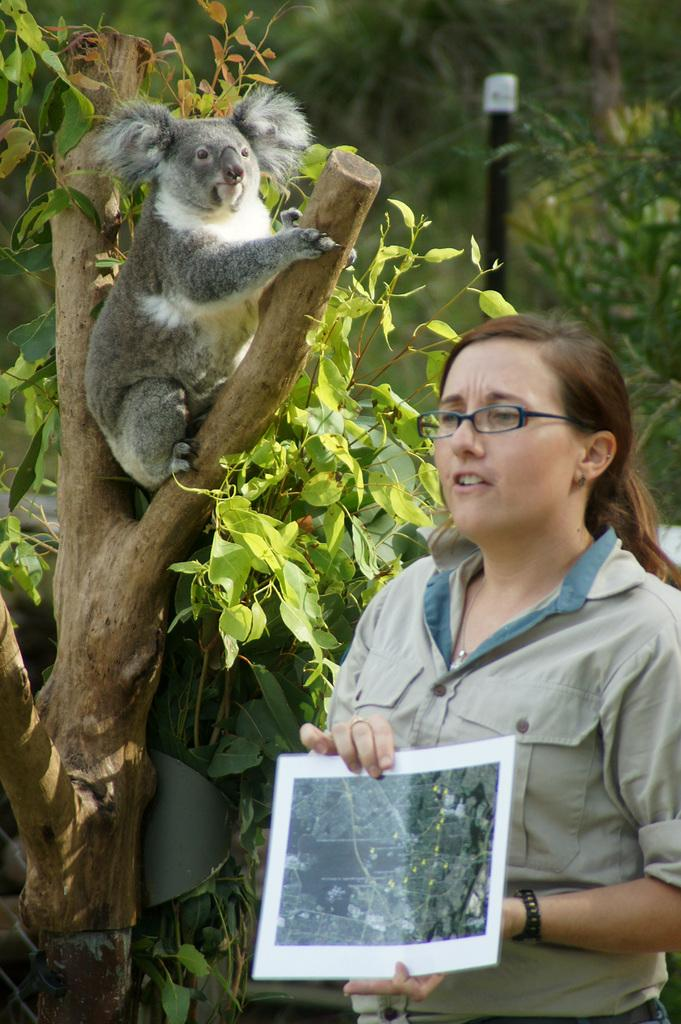Who is present in the image? There is a woman in the image. What is the woman holding in her hands? The woman is holding a paper in her hands. What accessory is the woman wearing? The woman is wearing spectacles. What type of natural environment can be seen in the image? There are trees in the image. What man-made object is present in the image? There is a pole in the image. What living creature can be seen in the image? There is an animal in the image. How many ducks are present on the woman's finger in the image? There are no ducks present in the image, and the woman's finger is not mentioned in the facts provided. What is the woman offering to the animal in the image? The facts provided do not mention any offering or interaction between the woman and the animal. 